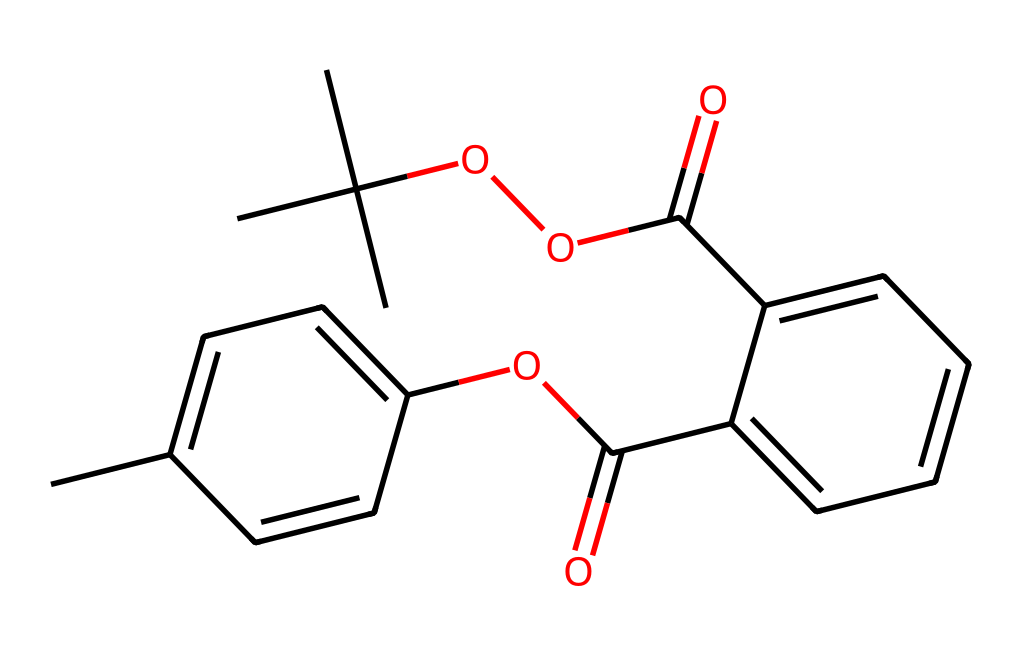What is the molecular formula represented in the SMILES? To derive the molecular formula from the SMILES, identify the different atoms present in the chemical structure. This SMILES indicates carbon (C), hydrogen (H), oxygen (O), and possibly other atoms involved in the bonds. Count the number of each type of atom to compile the molecular formula.
Answer: C19H20O5 How many rings are present in the structure? Examine the structure for any closed loops of carbon atoms. In this chemical, there are two distinct cyclic structures formed by carbon atoms, indicating two rings.
Answer: 2 What type of reaction mechanism is likely responsible for the luminescence? The glow of the chemical can be attributed to chemiluminescence, where a chemical reaction emits light. In this structure, the presence of certain functional groups and their ability to undergo reactions with oxygen triggers this light emission.
Answer: chemiluminescence What functional group is represented by "OC(=O)" in the SMILES? To identify the functional group, analyze the structure portion indicated by "OC(=O)" which signifies a carbon atom double-bonded to an oxygen atom and single-bonded to another oxygen atom (ester or acid). In the context of glow sticks, this represents an ester group.
Answer: ester How many carbon branches are present in the molecule? Review the structure to spot branching points, which occur when a carbon chain diverges from the main structure. This SMILES shows that there are two branching carbon groups, which contribute to the overall complexity and properties of the molecule.
Answer: 2 What type of chemical is this considered? Assess the overall characteristics of the chemical structure provided. Given the luminescent properties and the specific functional groups present, this chemical is classified as a photoreactive compound.
Answer: photoreactive 